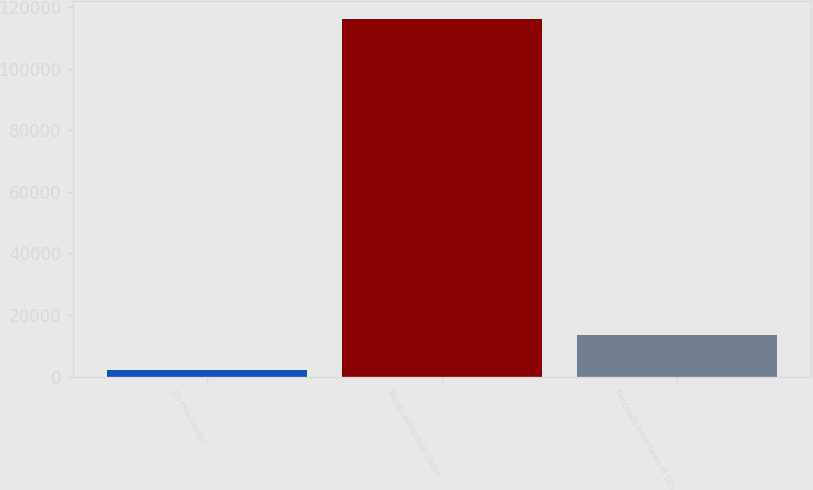Convert chart to OTSL. <chart><loc_0><loc_0><loc_500><loc_500><bar_chart><fcel>(In thousands)<fcel>Receivables sold under<fcel>Proceeds from sales of LCs<nl><fcel>2014<fcel>116292<fcel>13441.8<nl></chart> 